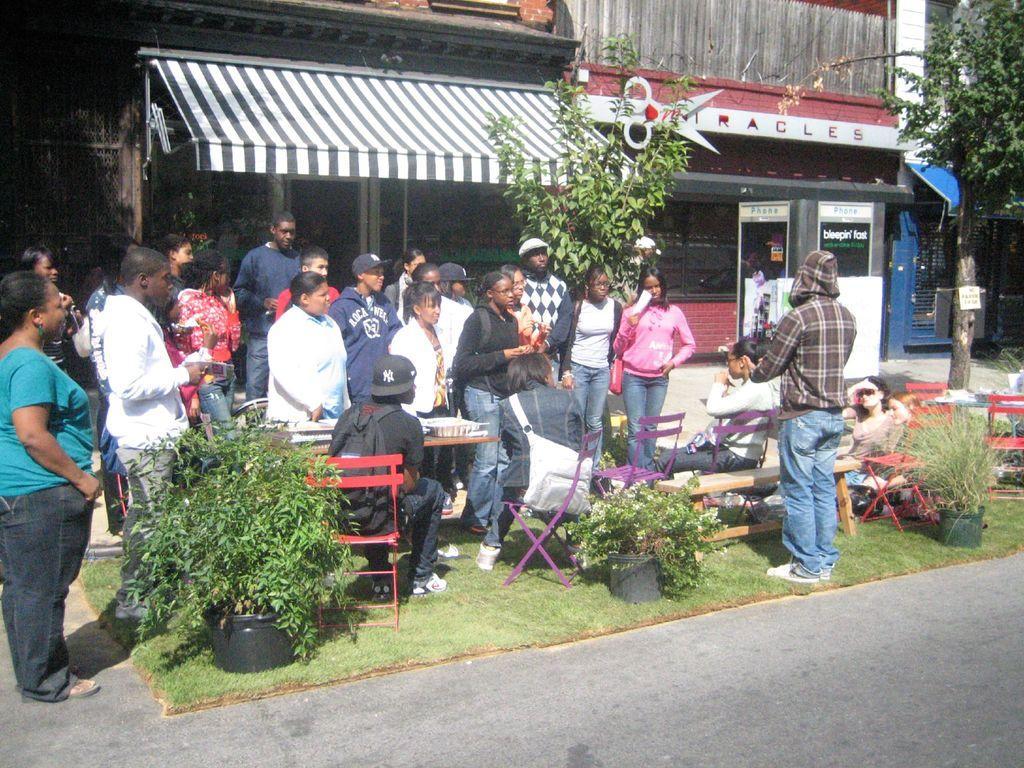How would you summarize this image in a sentence or two? In this picture there is a group for men and women standing in front and listen to the boy. Behind we can see the shops and canopy shed. On the right corner we can see the tree. 